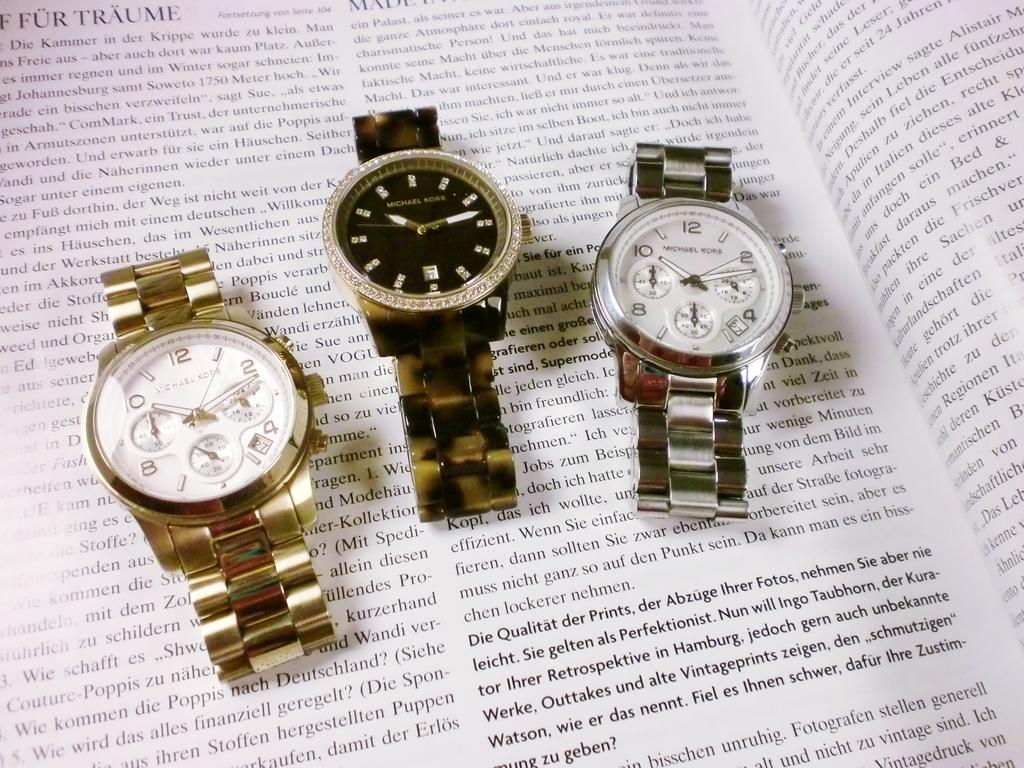How many watches are visible in the image? There are three watches in the image. What is the watches placed on? The watches are placed on a book. What type of garden can be seen in the image? There is no garden present in the image; it features three watches placed on a book. What material is the stick made of in the image? There is no stick present in the image. 